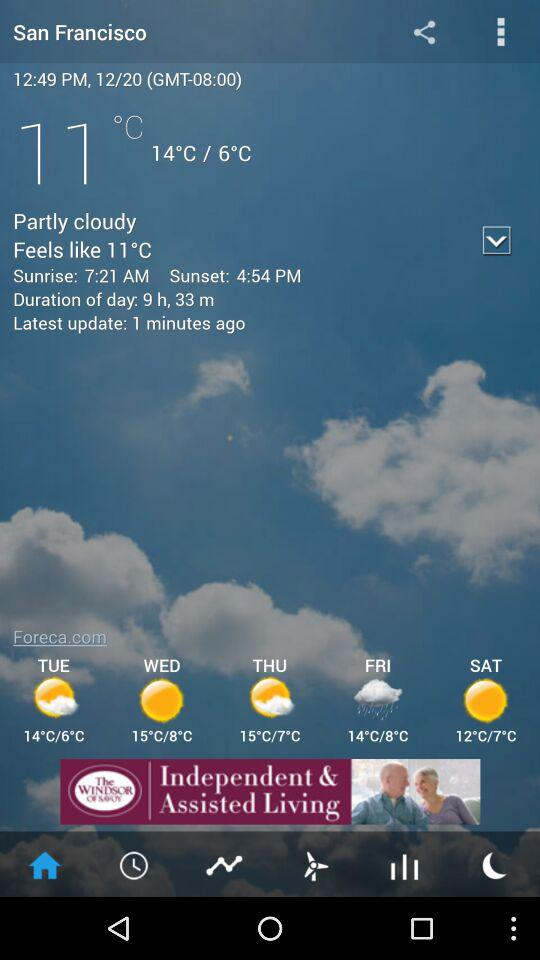What is the weather forecast for Friday? The weather forecast for Friday is rainy. 